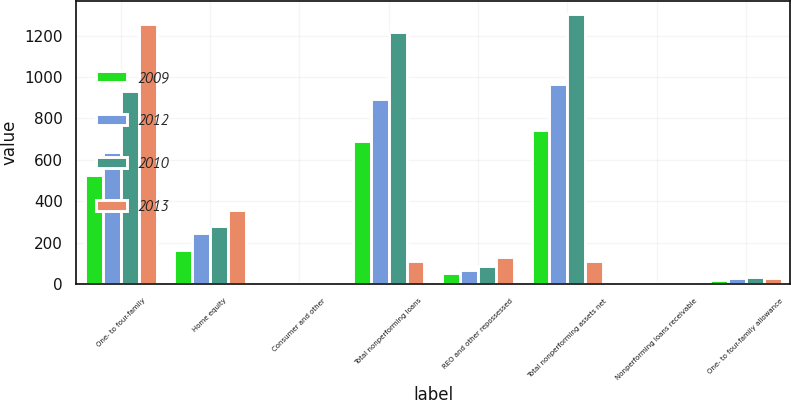Convert chart to OTSL. <chart><loc_0><loc_0><loc_500><loc_500><stacked_bar_chart><ecel><fcel>One- to four-family<fcel>Home equity<fcel>Consumer and other<fcel>Total nonperforming loans<fcel>REO and other repossessed<fcel>Total nonperforming assets net<fcel>Nonperforming loans receivable<fcel>One- to four-family allowance<nl><fcel>2009<fcel>525.5<fcel>164.4<fcel>2.8<fcel>692.7<fcel>53.2<fcel>745.9<fcel>8.08<fcel>19.46<nl><fcel>2012<fcel>639.1<fcel>247.5<fcel>6.4<fcel>893<fcel>71.2<fcel>964.2<fcel>8.44<fcel>28.77<nl><fcel>2010<fcel>930.2<fcel>281.4<fcel>4.5<fcel>1216.1<fcel>87.6<fcel>1303.7<fcel>9.24<fcel>33.78<nl><fcel>2013<fcel>1256.2<fcel>360.8<fcel>5.5<fcel>110.55<fcel>133.5<fcel>110.55<fcel>10.04<fcel>31.01<nl></chart> 